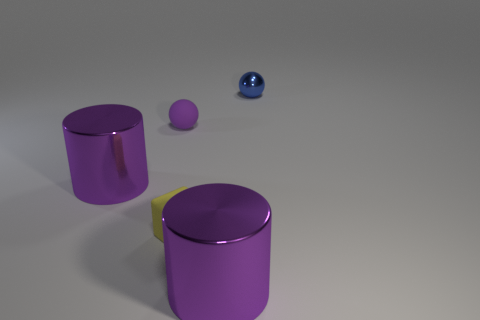Add 5 tiny matte objects. How many objects exist? 10 Subtract all spheres. How many objects are left? 3 Add 3 cubes. How many cubes exist? 4 Subtract 0 cyan cylinders. How many objects are left? 5 Subtract all big blue shiny balls. Subtract all small yellow cubes. How many objects are left? 4 Add 5 blue metal balls. How many blue metal balls are left? 6 